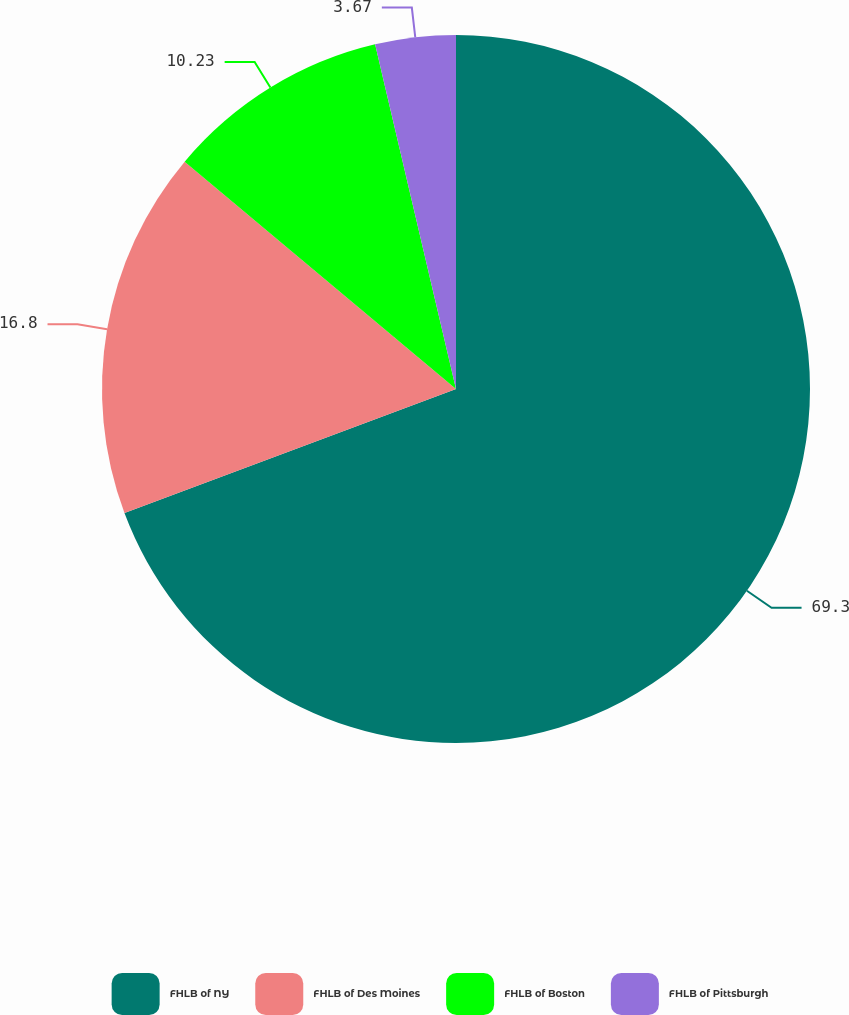Convert chart to OTSL. <chart><loc_0><loc_0><loc_500><loc_500><pie_chart><fcel>FHLB of NY<fcel>FHLB of Des Moines<fcel>FHLB of Boston<fcel>FHLB of Pittsburgh<nl><fcel>69.3%<fcel>16.8%<fcel>10.23%<fcel>3.67%<nl></chart> 